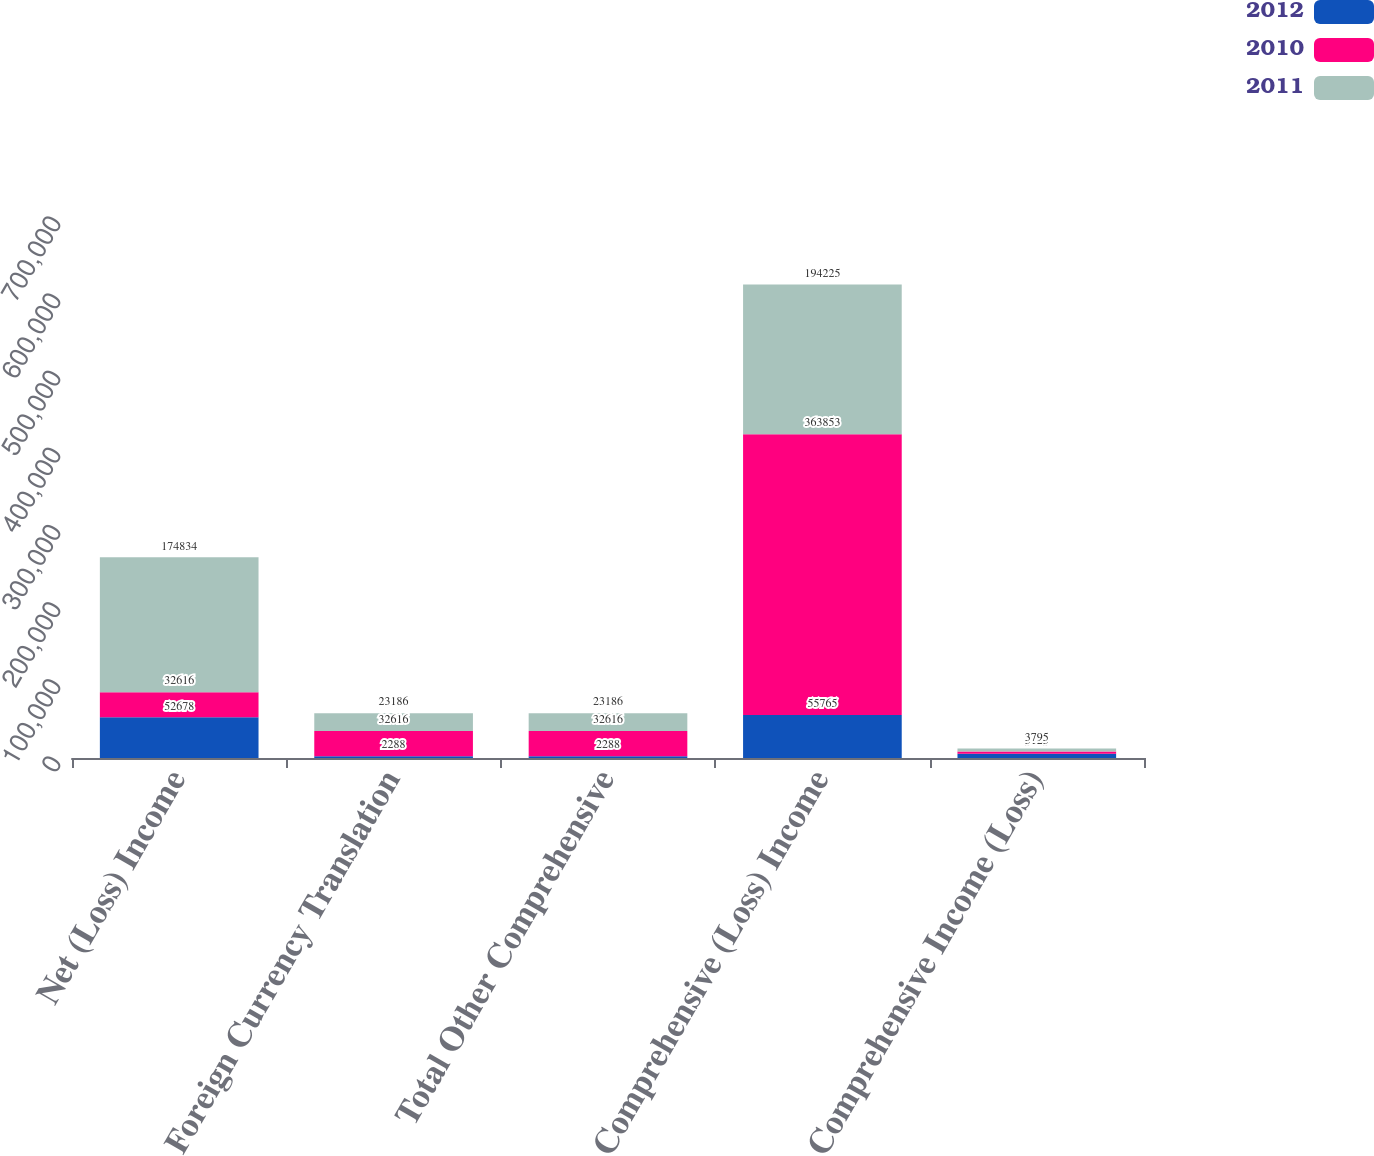Convert chart to OTSL. <chart><loc_0><loc_0><loc_500><loc_500><stacked_bar_chart><ecel><fcel>Net (Loss) Income<fcel>Foreign Currency Translation<fcel>Total Other Comprehensive<fcel>Comprehensive (Loss) Income<fcel>Comprehensive Income (Loss)<nl><fcel>2012<fcel>52678<fcel>2288<fcel>2288<fcel>55765<fcel>5375<nl><fcel>2010<fcel>32616<fcel>32616<fcel>32616<fcel>363853<fcel>3123<nl><fcel>2011<fcel>174834<fcel>23186<fcel>23186<fcel>194225<fcel>3795<nl></chart> 